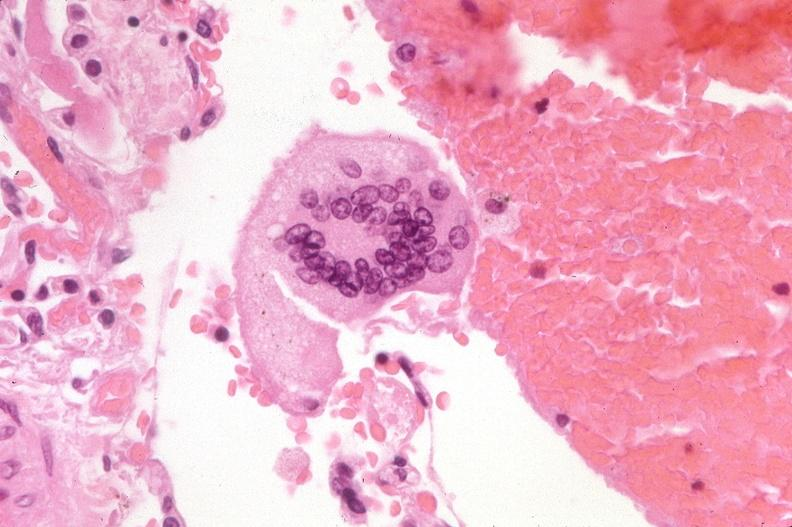does this image show lung, multinucleated foreign body giant cell?
Answer the question using a single word or phrase. Yes 